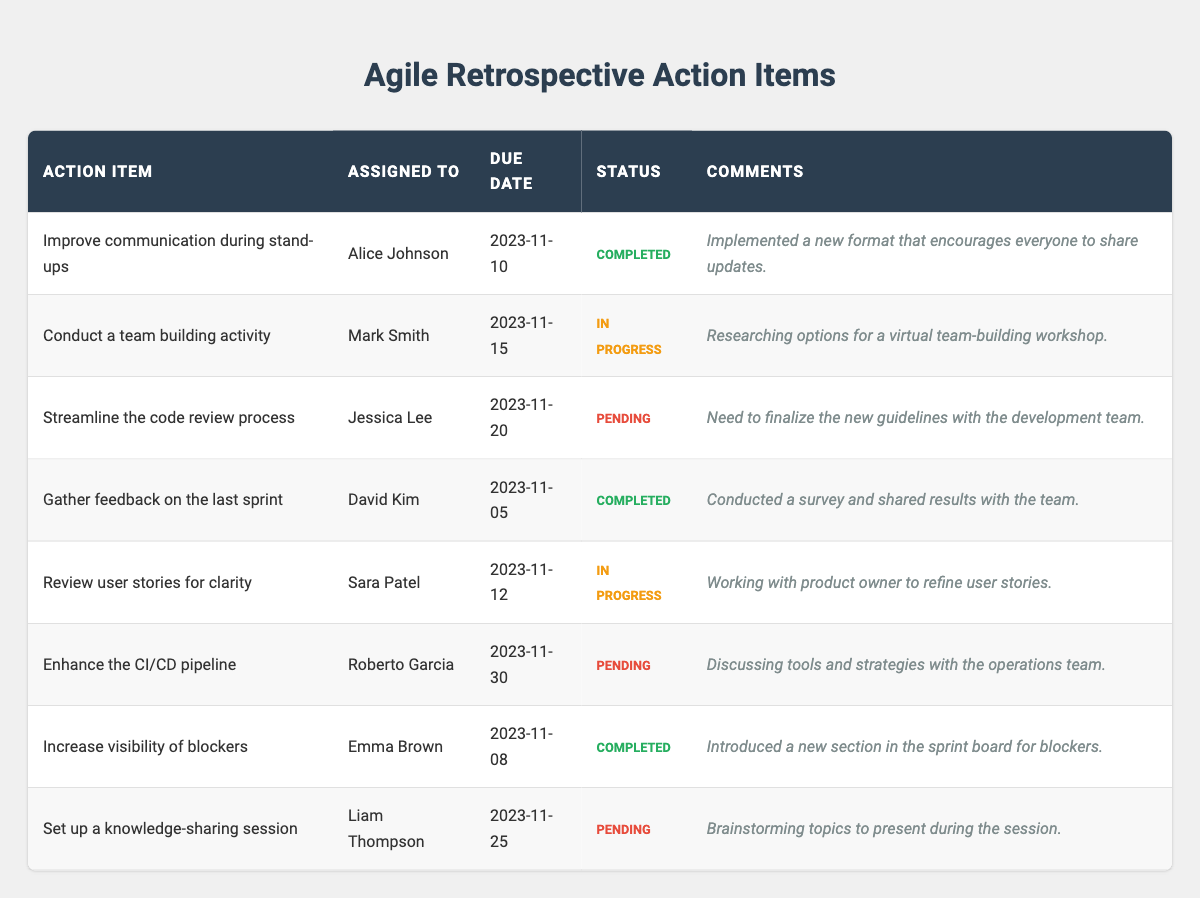What is the action item assigned to Alice Johnson? The table lists the action items and their assignees, and it shows that Alice Johnson is assigned to "Improve communication during stand-ups."
Answer: Improve communication during stand-ups How many action items are marked as "Completed"? By reviewing the completion status in the table, there are three action items that have "Completed" status: "Improve communication during stand-ups," "Gather feedback on the last sprint," and "Increase visibility of blockers."
Answer: 3 What is the due date for the action item assigned to Mark Smith? The table shows that the action item assigned to Mark Smith, which is "Conduct a team building activity," has a due date of November 15, 2023.
Answer: 2023-11-15 Is there an action item that is both "In Progress" and has a due date before November 20? The items with "In Progress" status include "Conduct a team building activity" (due Nov 15) and "Review user stories for clarity" (due Nov 12). Since "Review user stories for clarity" is also before November 20, the answer is yes.
Answer: Yes What are the comments for the action item with a due date of November 12? Looking at the table, the action item due on November 12 is "Review user stories for clarity," which has the comment: "Working with product owner to refine user stories."
Answer: Working with product owner to refine user stories Which action item has the latest due date? The action item with the latest due date is "Enhance the CI/CD pipeline," which is due on November 30, 2023. This can be determined by comparing the due dates of all action items.
Answer: Enhance the CI/CD pipeline How many action items are assigned to each team member who has completed their tasks? Alice Johnson and David Kim are both listed with completed tasks—Alice with "Improve communication during stand-ups" and David with "Gather feedback on the last sprint." Therefore, there are two completed action items assigned to two members.
Answer: 2 What percentage of action items are still "Pending"? There are 8 total action items, and 3 of them are "Pending." To find the percentage, we calculate (3/8) * 100 = 37.5%.
Answer: 37.5% Which action item has comments regarding a workshop? "Conduct a team building activity" contains comments about researching options for a virtual team-building workshop. This can be found by checking the comments in the relevant row of the table.
Answer: Conduct a team building activity Which team member has the most recent due date for their actions? The action item for David Kim, due on November 5, 2023, is the most recent. Checking all due dates shows that this is the earliest date.
Answer: David Kim 